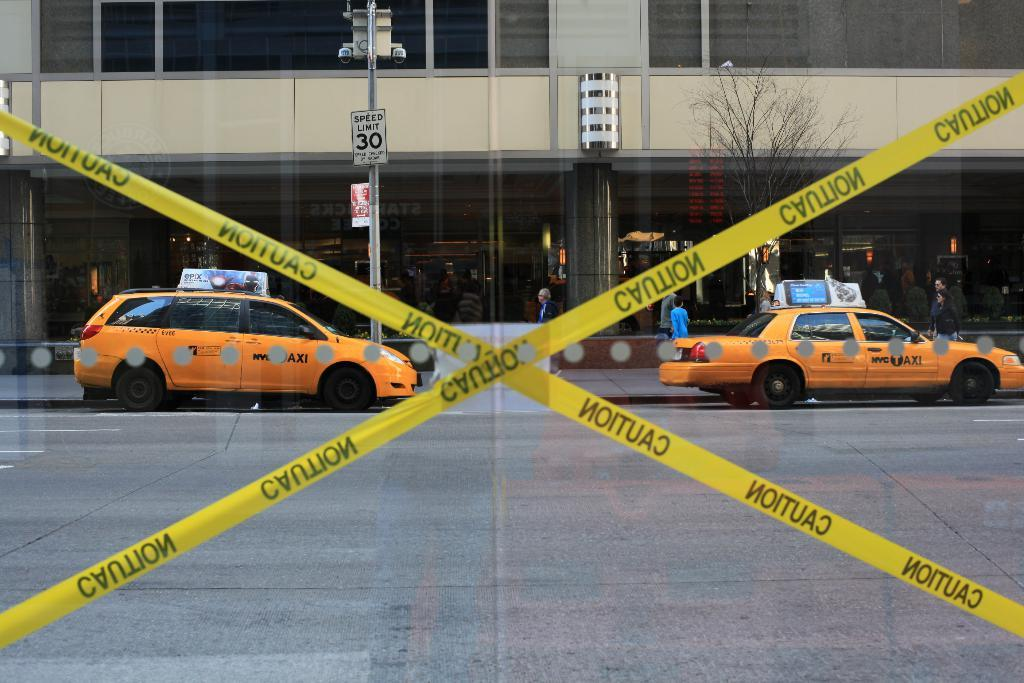<image>
Write a terse but informative summary of the picture. The window looking outside has caution tape on it. 